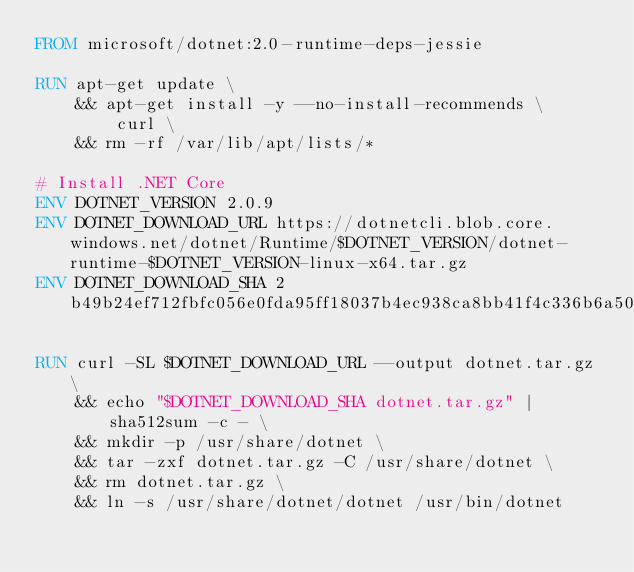<code> <loc_0><loc_0><loc_500><loc_500><_Dockerfile_>FROM microsoft/dotnet:2.0-runtime-deps-jessie

RUN apt-get update \
    && apt-get install -y --no-install-recommends \
        curl \
    && rm -rf /var/lib/apt/lists/*

# Install .NET Core
ENV DOTNET_VERSION 2.0.9
ENV DOTNET_DOWNLOAD_URL https://dotnetcli.blob.core.windows.net/dotnet/Runtime/$DOTNET_VERSION/dotnet-runtime-$DOTNET_VERSION-linux-x64.tar.gz
ENV DOTNET_DOWNLOAD_SHA 2b49b24ef712fbfc056e0fda95ff18037b4ec938ca8bb41f4c336b6a50870e922f5093684ac92c4bb8e1155b03c36d132d7f90817793f31c9ade5267fff6629a

RUN curl -SL $DOTNET_DOWNLOAD_URL --output dotnet.tar.gz \
    && echo "$DOTNET_DOWNLOAD_SHA dotnet.tar.gz" | sha512sum -c - \
    && mkdir -p /usr/share/dotnet \
    && tar -zxf dotnet.tar.gz -C /usr/share/dotnet \
    && rm dotnet.tar.gz \
    && ln -s /usr/share/dotnet/dotnet /usr/bin/dotnet
</code> 